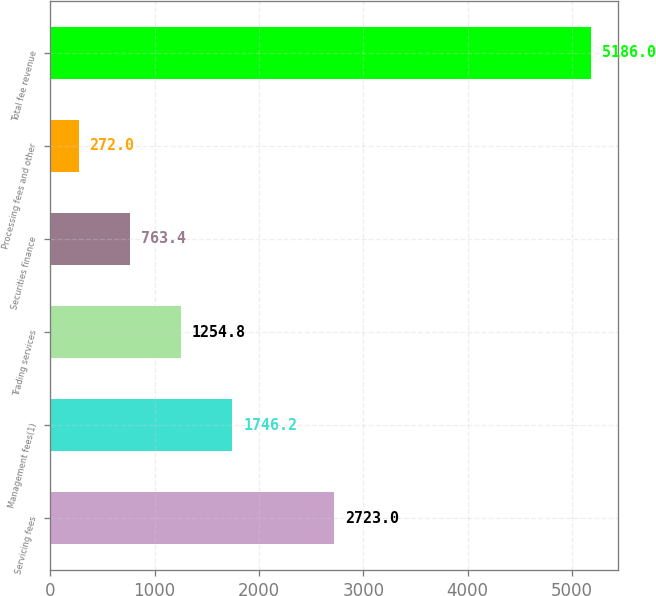Convert chart to OTSL. <chart><loc_0><loc_0><loc_500><loc_500><bar_chart><fcel>Servicing fees<fcel>Management fees(1)<fcel>Trading services<fcel>Securities finance<fcel>Processing fees and other<fcel>Total fee revenue<nl><fcel>2723<fcel>1746.2<fcel>1254.8<fcel>763.4<fcel>272<fcel>5186<nl></chart> 